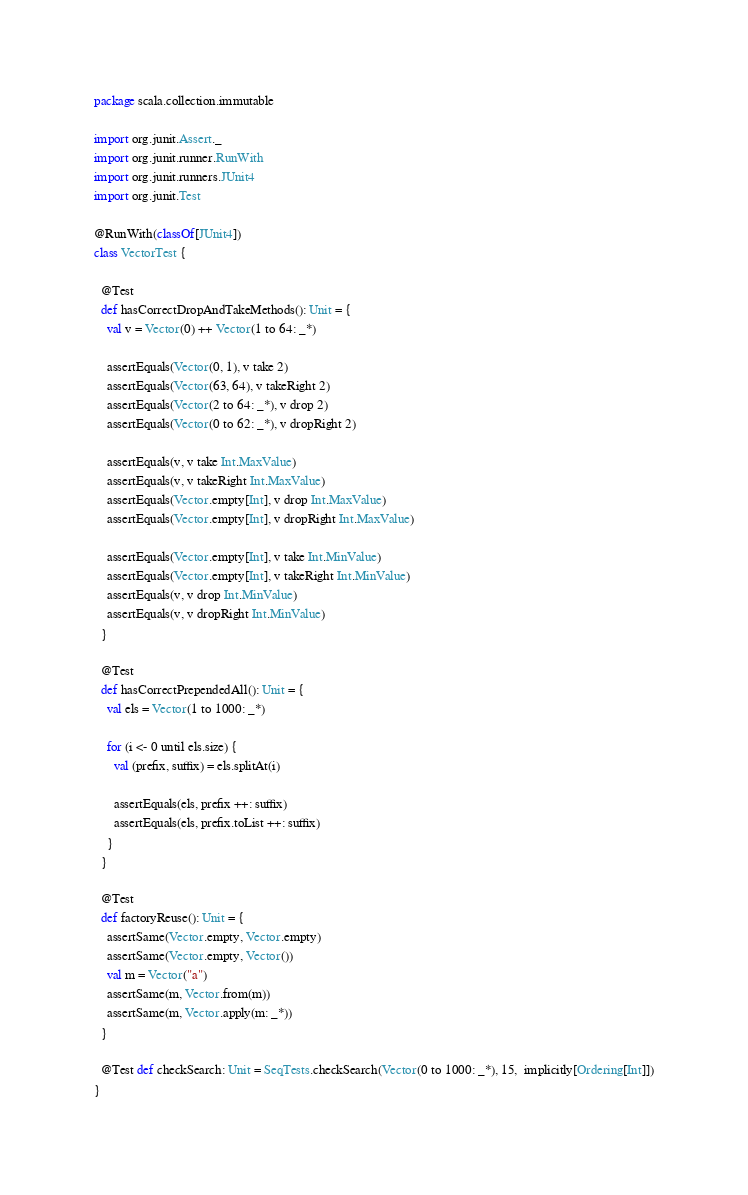<code> <loc_0><loc_0><loc_500><loc_500><_Scala_>package scala.collection.immutable

import org.junit.Assert._
import org.junit.runner.RunWith
import org.junit.runners.JUnit4
import org.junit.Test

@RunWith(classOf[JUnit4])
class VectorTest {

  @Test
  def hasCorrectDropAndTakeMethods(): Unit = {
    val v = Vector(0) ++ Vector(1 to 64: _*)

    assertEquals(Vector(0, 1), v take 2)
    assertEquals(Vector(63, 64), v takeRight 2)
    assertEquals(Vector(2 to 64: _*), v drop 2)
    assertEquals(Vector(0 to 62: _*), v dropRight 2)

    assertEquals(v, v take Int.MaxValue)
    assertEquals(v, v takeRight Int.MaxValue)
    assertEquals(Vector.empty[Int], v drop Int.MaxValue)
    assertEquals(Vector.empty[Int], v dropRight Int.MaxValue)

    assertEquals(Vector.empty[Int], v take Int.MinValue)
    assertEquals(Vector.empty[Int], v takeRight Int.MinValue)
    assertEquals(v, v drop Int.MinValue)
    assertEquals(v, v dropRight Int.MinValue)
  }

  @Test
  def hasCorrectPrependedAll(): Unit = {
    val els = Vector(1 to 1000: _*)

    for (i <- 0 until els.size) {
      val (prefix, suffix) = els.splitAt(i)

      assertEquals(els, prefix ++: suffix)
      assertEquals(els, prefix.toList ++: suffix)
    }
  }

  @Test
  def factoryReuse(): Unit = {
    assertSame(Vector.empty, Vector.empty)
    assertSame(Vector.empty, Vector())
    val m = Vector("a")
    assertSame(m, Vector.from(m))
    assertSame(m, Vector.apply(m: _*))
  }

  @Test def checkSearch: Unit = SeqTests.checkSearch(Vector(0 to 1000: _*), 15,  implicitly[Ordering[Int]])
}
</code> 